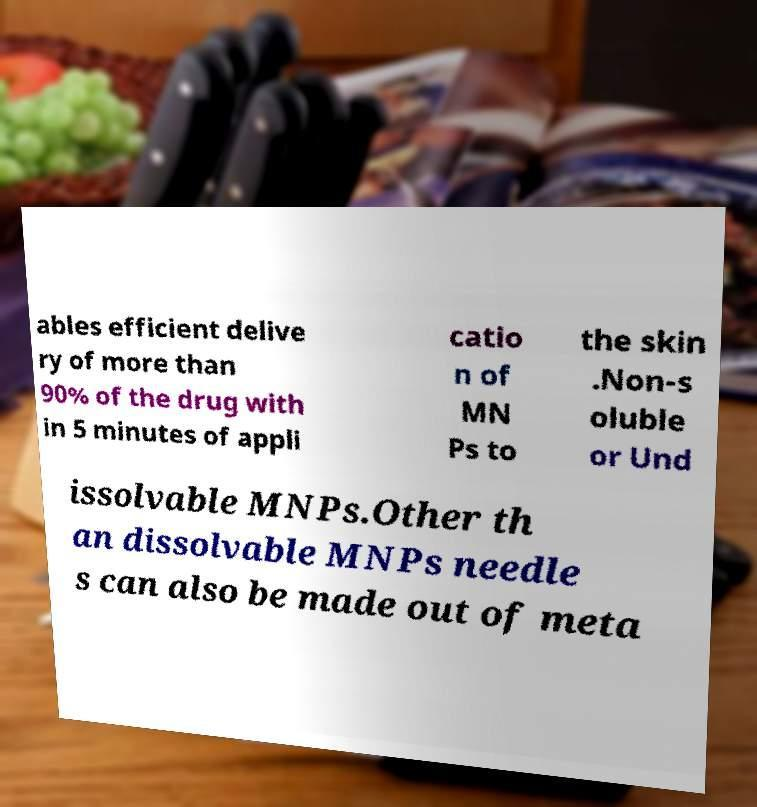Can you read and provide the text displayed in the image?This photo seems to have some interesting text. Can you extract and type it out for me? ables efficient delive ry of more than 90% of the drug with in 5 minutes of appli catio n of MN Ps to the skin .Non-s oluble or Und issolvable MNPs.Other th an dissolvable MNPs needle s can also be made out of meta 